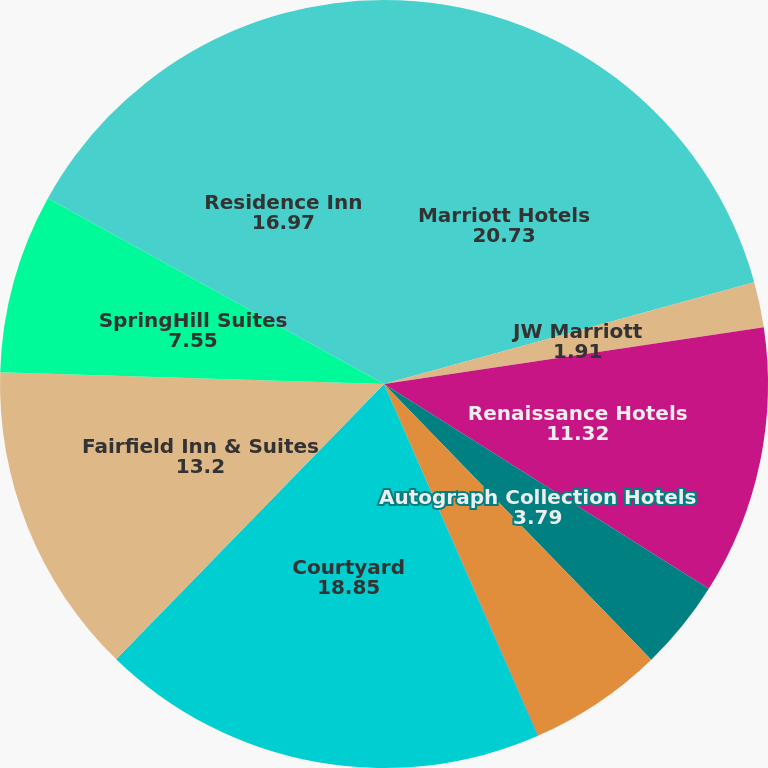Convert chart. <chart><loc_0><loc_0><loc_500><loc_500><pie_chart><fcel>Marriott Hotels<fcel>JW Marriott<fcel>Renaissance Hotels<fcel>Autograph Collection Hotels<fcel>The Ritz-Carlton<fcel>The Ritz-Carlton Residences<fcel>Courtyard<fcel>Fairfield Inn & Suites<fcel>SpringHill Suites<fcel>Residence Inn<nl><fcel>20.73%<fcel>1.91%<fcel>11.32%<fcel>3.79%<fcel>5.67%<fcel>0.02%<fcel>18.85%<fcel>13.2%<fcel>7.55%<fcel>16.97%<nl></chart> 